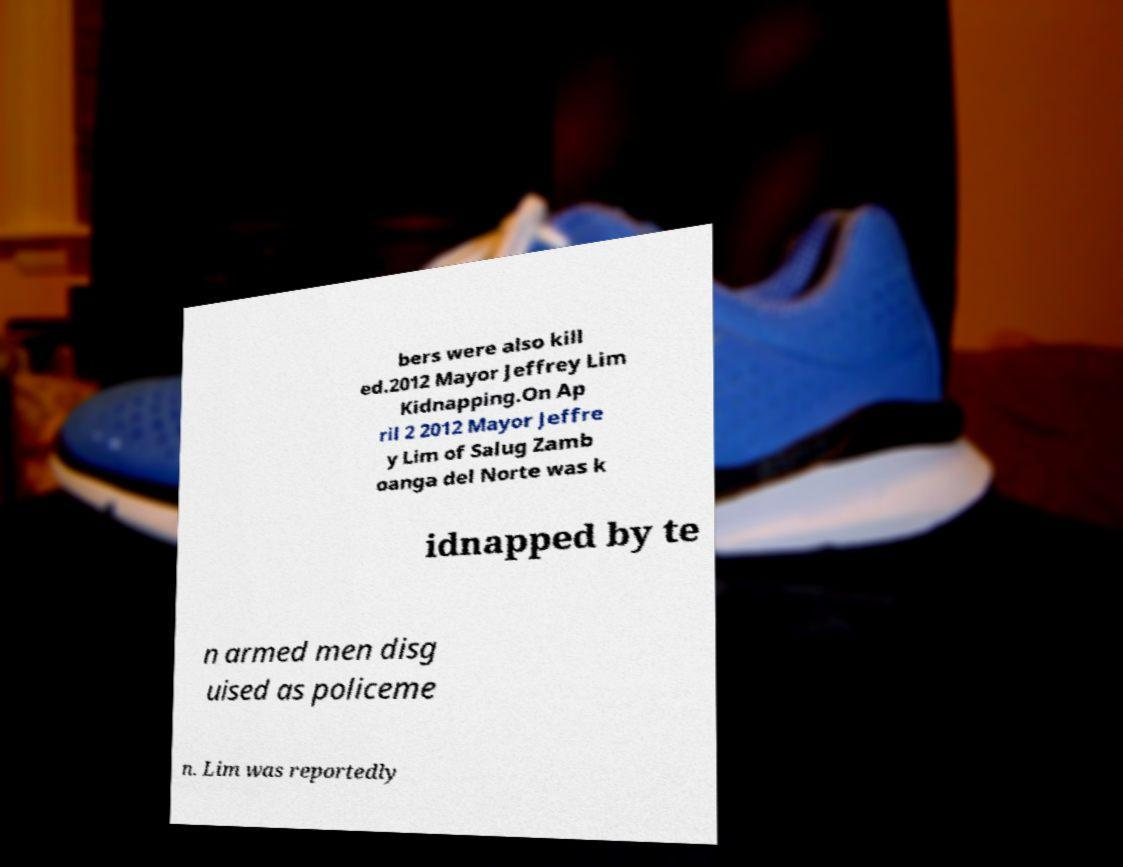Could you assist in decoding the text presented in this image and type it out clearly? bers were also kill ed.2012 Mayor Jeffrey Lim Kidnapping.On Ap ril 2 2012 Mayor Jeffre y Lim of Salug Zamb oanga del Norte was k idnapped by te n armed men disg uised as policeme n. Lim was reportedly 